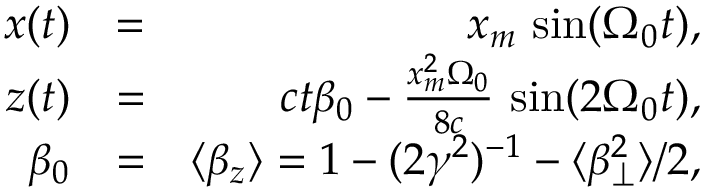<formula> <loc_0><loc_0><loc_500><loc_500>\begin{array} { r l r } { x ( t ) } & { = } & { x _ { m } \, \sin ( \Omega _ { 0 } t ) , } \\ { z ( t ) } & { = } & { c t \beta _ { 0 } - \frac { x _ { m } ^ { 2 } \Omega _ { 0 } } { 8 c } \, \sin ( 2 \Omega _ { 0 } t ) , } \\ { \beta _ { 0 } } & { = } & { \langle \beta _ { z } \rangle = 1 - ( 2 \gamma ^ { 2 } ) ^ { - 1 } - \langle \beta _ { \perp } ^ { 2 } \rangle / 2 , } \end{array}</formula> 